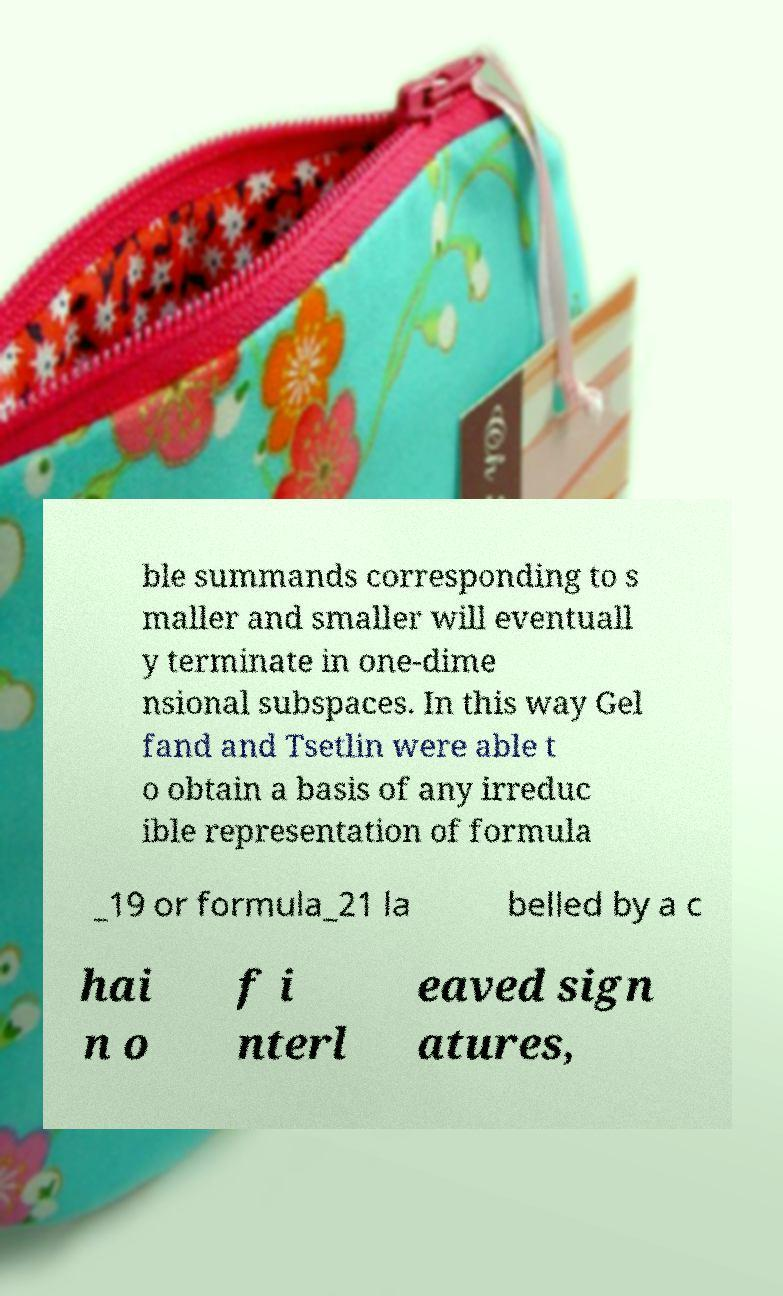Please read and relay the text visible in this image. What does it say? ble summands corresponding to s maller and smaller will eventuall y terminate in one-dime nsional subspaces. In this way Gel fand and Tsetlin were able t o obtain a basis of any irreduc ible representation of formula _19 or formula_21 la belled by a c hai n o f i nterl eaved sign atures, 